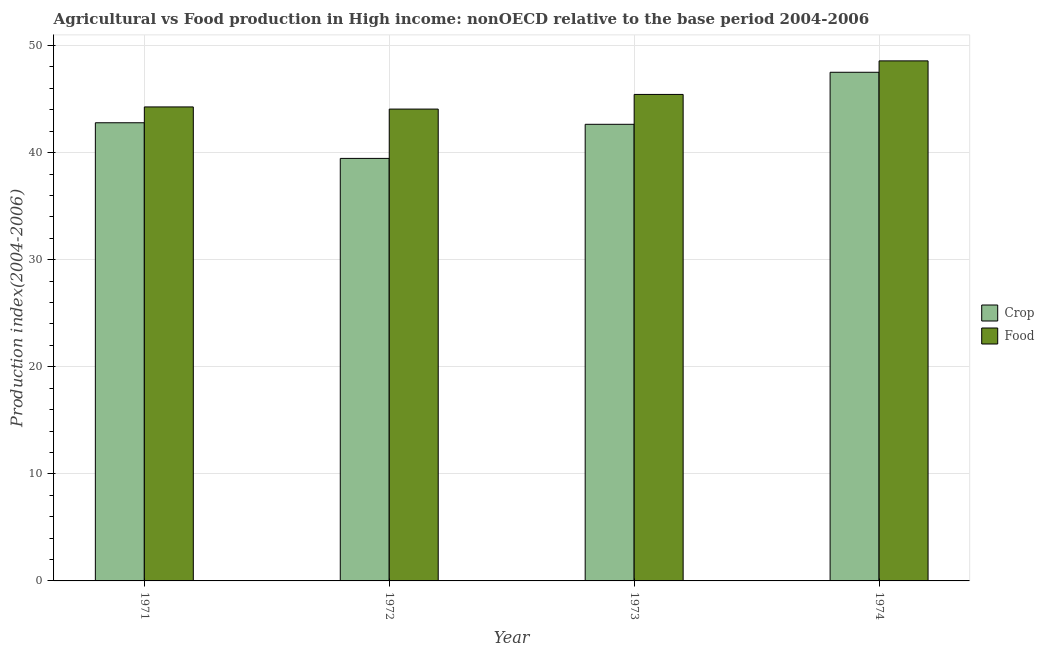How many groups of bars are there?
Provide a succinct answer. 4. Are the number of bars per tick equal to the number of legend labels?
Your response must be concise. Yes. How many bars are there on the 2nd tick from the left?
Make the answer very short. 2. How many bars are there on the 1st tick from the right?
Ensure brevity in your answer.  2. What is the food production index in 1972?
Give a very brief answer. 44.06. Across all years, what is the maximum food production index?
Make the answer very short. 48.56. Across all years, what is the minimum crop production index?
Keep it short and to the point. 39.46. In which year was the food production index maximum?
Provide a succinct answer. 1974. What is the total crop production index in the graph?
Give a very brief answer. 172.38. What is the difference between the crop production index in 1972 and that in 1973?
Make the answer very short. -3.18. What is the difference between the crop production index in 1971 and the food production index in 1973?
Offer a very short reply. 0.14. What is the average food production index per year?
Make the answer very short. 45.58. In the year 1972, what is the difference between the crop production index and food production index?
Give a very brief answer. 0. In how many years, is the food production index greater than 18?
Your response must be concise. 4. What is the ratio of the food production index in 1971 to that in 1973?
Offer a very short reply. 0.97. Is the crop production index in 1973 less than that in 1974?
Your answer should be compact. Yes. Is the difference between the crop production index in 1973 and 1974 greater than the difference between the food production index in 1973 and 1974?
Ensure brevity in your answer.  No. What is the difference between the highest and the second highest food production index?
Your answer should be very brief. 3.13. What is the difference between the highest and the lowest food production index?
Your answer should be very brief. 4.5. What does the 2nd bar from the left in 1971 represents?
Keep it short and to the point. Food. What does the 2nd bar from the right in 1974 represents?
Give a very brief answer. Crop. Are all the bars in the graph horizontal?
Make the answer very short. No. Are the values on the major ticks of Y-axis written in scientific E-notation?
Give a very brief answer. No. Where does the legend appear in the graph?
Provide a succinct answer. Center right. How are the legend labels stacked?
Provide a succinct answer. Vertical. What is the title of the graph?
Provide a succinct answer. Agricultural vs Food production in High income: nonOECD relative to the base period 2004-2006. What is the label or title of the Y-axis?
Offer a terse response. Production index(2004-2006). What is the Production index(2004-2006) in Crop in 1971?
Offer a terse response. 42.79. What is the Production index(2004-2006) in Food in 1971?
Your answer should be compact. 44.26. What is the Production index(2004-2006) of Crop in 1972?
Keep it short and to the point. 39.46. What is the Production index(2004-2006) of Food in 1972?
Your response must be concise. 44.06. What is the Production index(2004-2006) of Crop in 1973?
Provide a succinct answer. 42.64. What is the Production index(2004-2006) in Food in 1973?
Your response must be concise. 45.43. What is the Production index(2004-2006) of Crop in 1974?
Ensure brevity in your answer.  47.5. What is the Production index(2004-2006) in Food in 1974?
Offer a terse response. 48.56. Across all years, what is the maximum Production index(2004-2006) of Crop?
Provide a short and direct response. 47.5. Across all years, what is the maximum Production index(2004-2006) in Food?
Make the answer very short. 48.56. Across all years, what is the minimum Production index(2004-2006) of Crop?
Ensure brevity in your answer.  39.46. Across all years, what is the minimum Production index(2004-2006) in Food?
Offer a very short reply. 44.06. What is the total Production index(2004-2006) of Crop in the graph?
Your answer should be very brief. 172.38. What is the total Production index(2004-2006) of Food in the graph?
Ensure brevity in your answer.  182.32. What is the difference between the Production index(2004-2006) of Crop in 1971 and that in 1972?
Your answer should be very brief. 3.33. What is the difference between the Production index(2004-2006) in Food in 1971 and that in 1972?
Provide a short and direct response. 0.2. What is the difference between the Production index(2004-2006) of Crop in 1971 and that in 1973?
Give a very brief answer. 0.14. What is the difference between the Production index(2004-2006) of Food in 1971 and that in 1973?
Make the answer very short. -1.17. What is the difference between the Production index(2004-2006) of Crop in 1971 and that in 1974?
Make the answer very short. -4.71. What is the difference between the Production index(2004-2006) of Food in 1971 and that in 1974?
Make the answer very short. -4.3. What is the difference between the Production index(2004-2006) of Crop in 1972 and that in 1973?
Offer a very short reply. -3.18. What is the difference between the Production index(2004-2006) in Food in 1972 and that in 1973?
Your answer should be very brief. -1.37. What is the difference between the Production index(2004-2006) in Crop in 1972 and that in 1974?
Offer a very short reply. -8.04. What is the difference between the Production index(2004-2006) of Food in 1972 and that in 1974?
Ensure brevity in your answer.  -4.5. What is the difference between the Production index(2004-2006) in Crop in 1973 and that in 1974?
Your answer should be compact. -4.86. What is the difference between the Production index(2004-2006) of Food in 1973 and that in 1974?
Your response must be concise. -3.13. What is the difference between the Production index(2004-2006) of Crop in 1971 and the Production index(2004-2006) of Food in 1972?
Your answer should be compact. -1.28. What is the difference between the Production index(2004-2006) of Crop in 1971 and the Production index(2004-2006) of Food in 1973?
Your response must be concise. -2.64. What is the difference between the Production index(2004-2006) in Crop in 1971 and the Production index(2004-2006) in Food in 1974?
Make the answer very short. -5.78. What is the difference between the Production index(2004-2006) of Crop in 1972 and the Production index(2004-2006) of Food in 1973?
Give a very brief answer. -5.97. What is the difference between the Production index(2004-2006) of Crop in 1972 and the Production index(2004-2006) of Food in 1974?
Ensure brevity in your answer.  -9.11. What is the difference between the Production index(2004-2006) of Crop in 1973 and the Production index(2004-2006) of Food in 1974?
Your response must be concise. -5.92. What is the average Production index(2004-2006) in Crop per year?
Your answer should be compact. 43.1. What is the average Production index(2004-2006) in Food per year?
Provide a succinct answer. 45.58. In the year 1971, what is the difference between the Production index(2004-2006) in Crop and Production index(2004-2006) in Food?
Provide a succinct answer. -1.48. In the year 1972, what is the difference between the Production index(2004-2006) of Crop and Production index(2004-2006) of Food?
Provide a succinct answer. -4.61. In the year 1973, what is the difference between the Production index(2004-2006) of Crop and Production index(2004-2006) of Food?
Offer a terse response. -2.79. In the year 1974, what is the difference between the Production index(2004-2006) in Crop and Production index(2004-2006) in Food?
Keep it short and to the point. -1.06. What is the ratio of the Production index(2004-2006) in Crop in 1971 to that in 1972?
Your response must be concise. 1.08. What is the ratio of the Production index(2004-2006) in Food in 1971 to that in 1972?
Your answer should be very brief. 1. What is the ratio of the Production index(2004-2006) in Food in 1971 to that in 1973?
Give a very brief answer. 0.97. What is the ratio of the Production index(2004-2006) in Crop in 1971 to that in 1974?
Ensure brevity in your answer.  0.9. What is the ratio of the Production index(2004-2006) in Food in 1971 to that in 1974?
Give a very brief answer. 0.91. What is the ratio of the Production index(2004-2006) in Crop in 1972 to that in 1973?
Offer a very short reply. 0.93. What is the ratio of the Production index(2004-2006) in Food in 1972 to that in 1973?
Make the answer very short. 0.97. What is the ratio of the Production index(2004-2006) of Crop in 1972 to that in 1974?
Ensure brevity in your answer.  0.83. What is the ratio of the Production index(2004-2006) of Food in 1972 to that in 1974?
Give a very brief answer. 0.91. What is the ratio of the Production index(2004-2006) of Crop in 1973 to that in 1974?
Your answer should be very brief. 0.9. What is the ratio of the Production index(2004-2006) in Food in 1973 to that in 1974?
Ensure brevity in your answer.  0.94. What is the difference between the highest and the second highest Production index(2004-2006) of Crop?
Provide a succinct answer. 4.71. What is the difference between the highest and the second highest Production index(2004-2006) of Food?
Offer a terse response. 3.13. What is the difference between the highest and the lowest Production index(2004-2006) in Crop?
Offer a very short reply. 8.04. What is the difference between the highest and the lowest Production index(2004-2006) of Food?
Give a very brief answer. 4.5. 